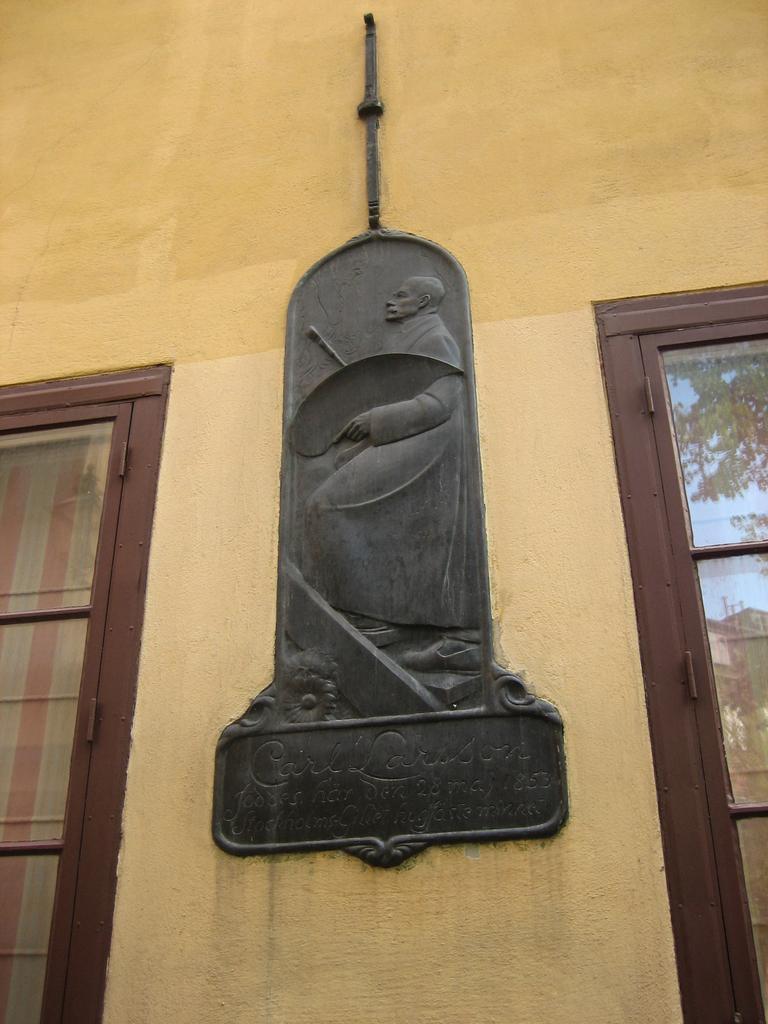Describe this image in one or two sentences. In this image we can see few windows. We can see the reflection of a building and a tree on the window glass at the right side of the image. We can see the sculpture of a person on the wall. 